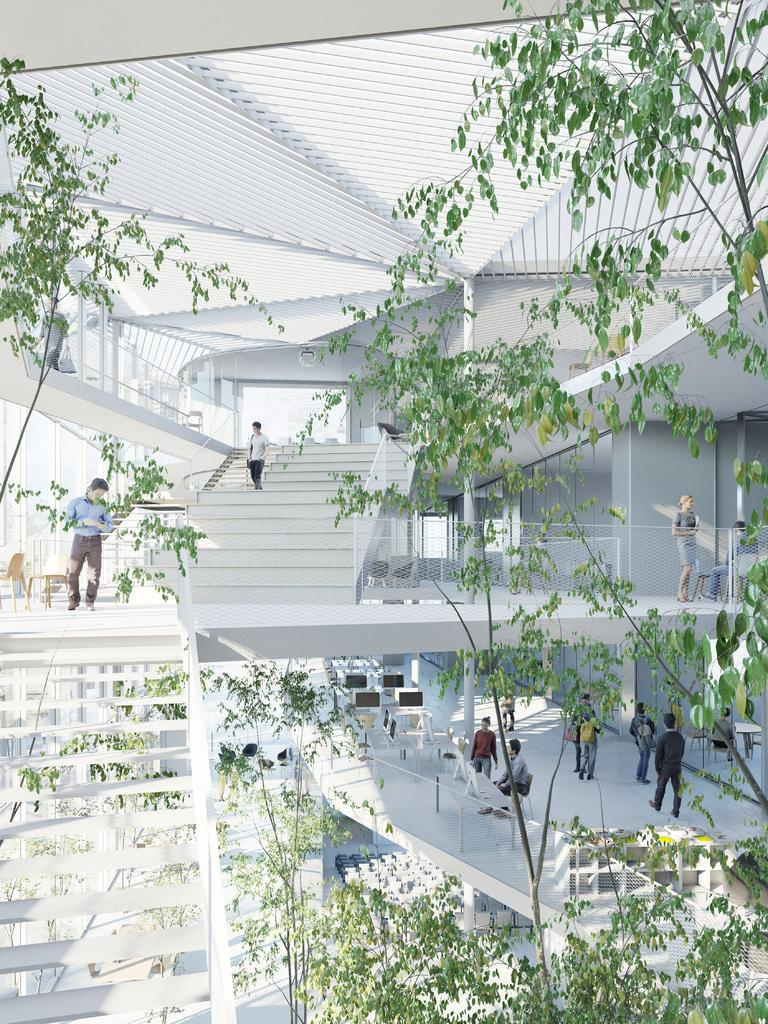What type of natural elements can be seen in the image? There are trees in the image. What type of furniture is visible in the image? There are chairs in the image. What architectural feature is present in front of the image? There are stairs in front of the image. Can you describe the people inside the building? There are people standing inside the building. What type of ground is visible in the image? There is no ground visible in the image; it only shows trees, chairs, stairs, and people inside a building. What time of day is depicted in the image? The time of day cannot be determined from the image, as there are no specific indicators of time. 